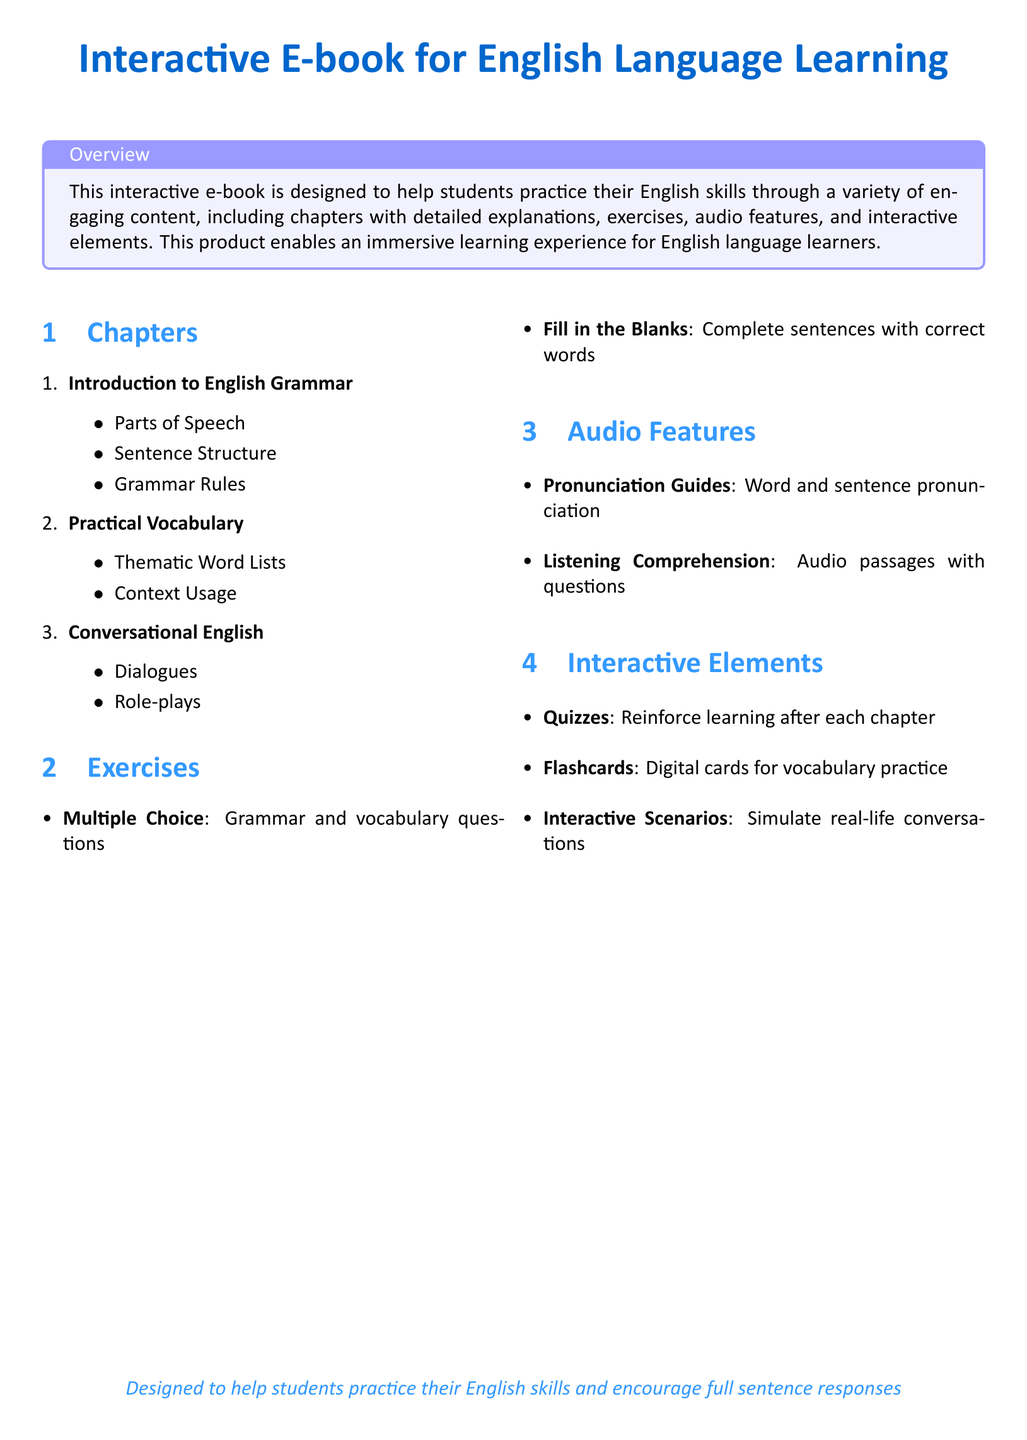What is the title of the e-book? The title is stated at the beginning of the document and is “Interactive E-book for English Language Learning.”
Answer: Interactive E-book for English Language Learning How many chapters are listed in the document? The chapters are enumerated in the document, and there are three chapters mentioned.
Answer: 3 What is the first chapter about? The first chapter is described in the list of chapters, which is “Introduction to English Grammar.”
Answer: Introduction to English Grammar What type of exercise includes completing sentences? The exercise type is listed under the exercises section, which is “Fill in the Blanks.”
Answer: Fill in the Blanks What audio feature is used for word pronunciation? The audio feature is specified in the audio features section as “Pronunciation Guides.”
Answer: Pronunciation Guides What kind of interactive element simulates real-life conversations? The interactive element is detailed in the interactive elements section, which is “Interactive Scenarios.”
Answer: Interactive Scenarios What is the primary purpose of the e-book? The document provides an overview that states the purpose, which is to help students practice their English skills.
Answer: Help students practice their English skills What format does the document predominantly use? The document is specified to be a specification sheet meant for discussing products, evidenced by its structured sections.
Answer: Product specification sheet 